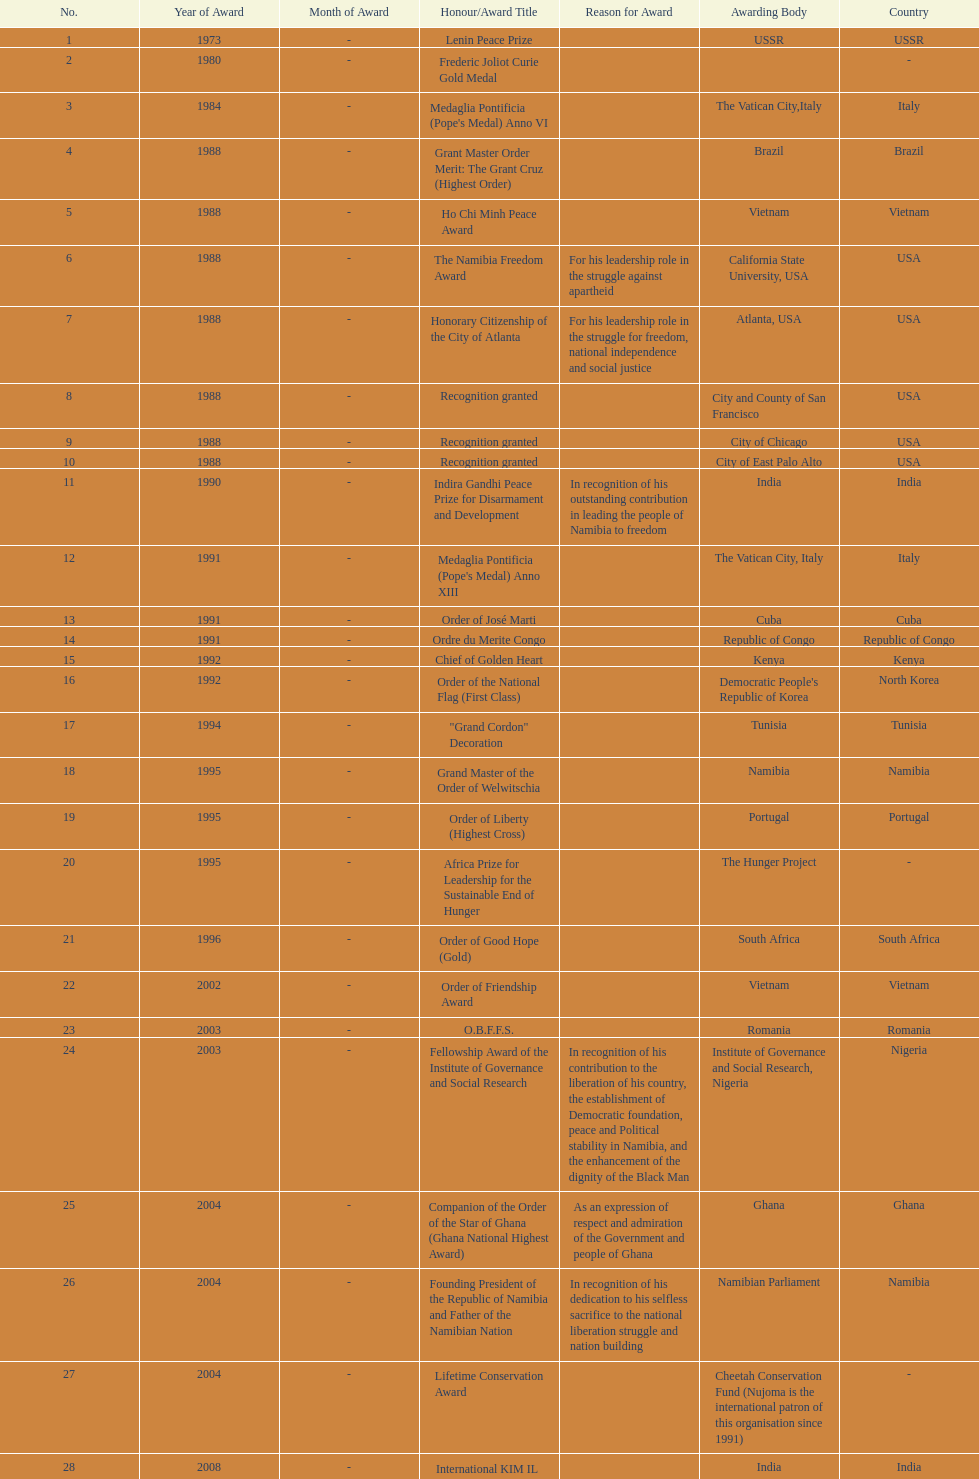What is the last honors/award title listed on this chart? Sir Seretse Khama SADC Meda. 